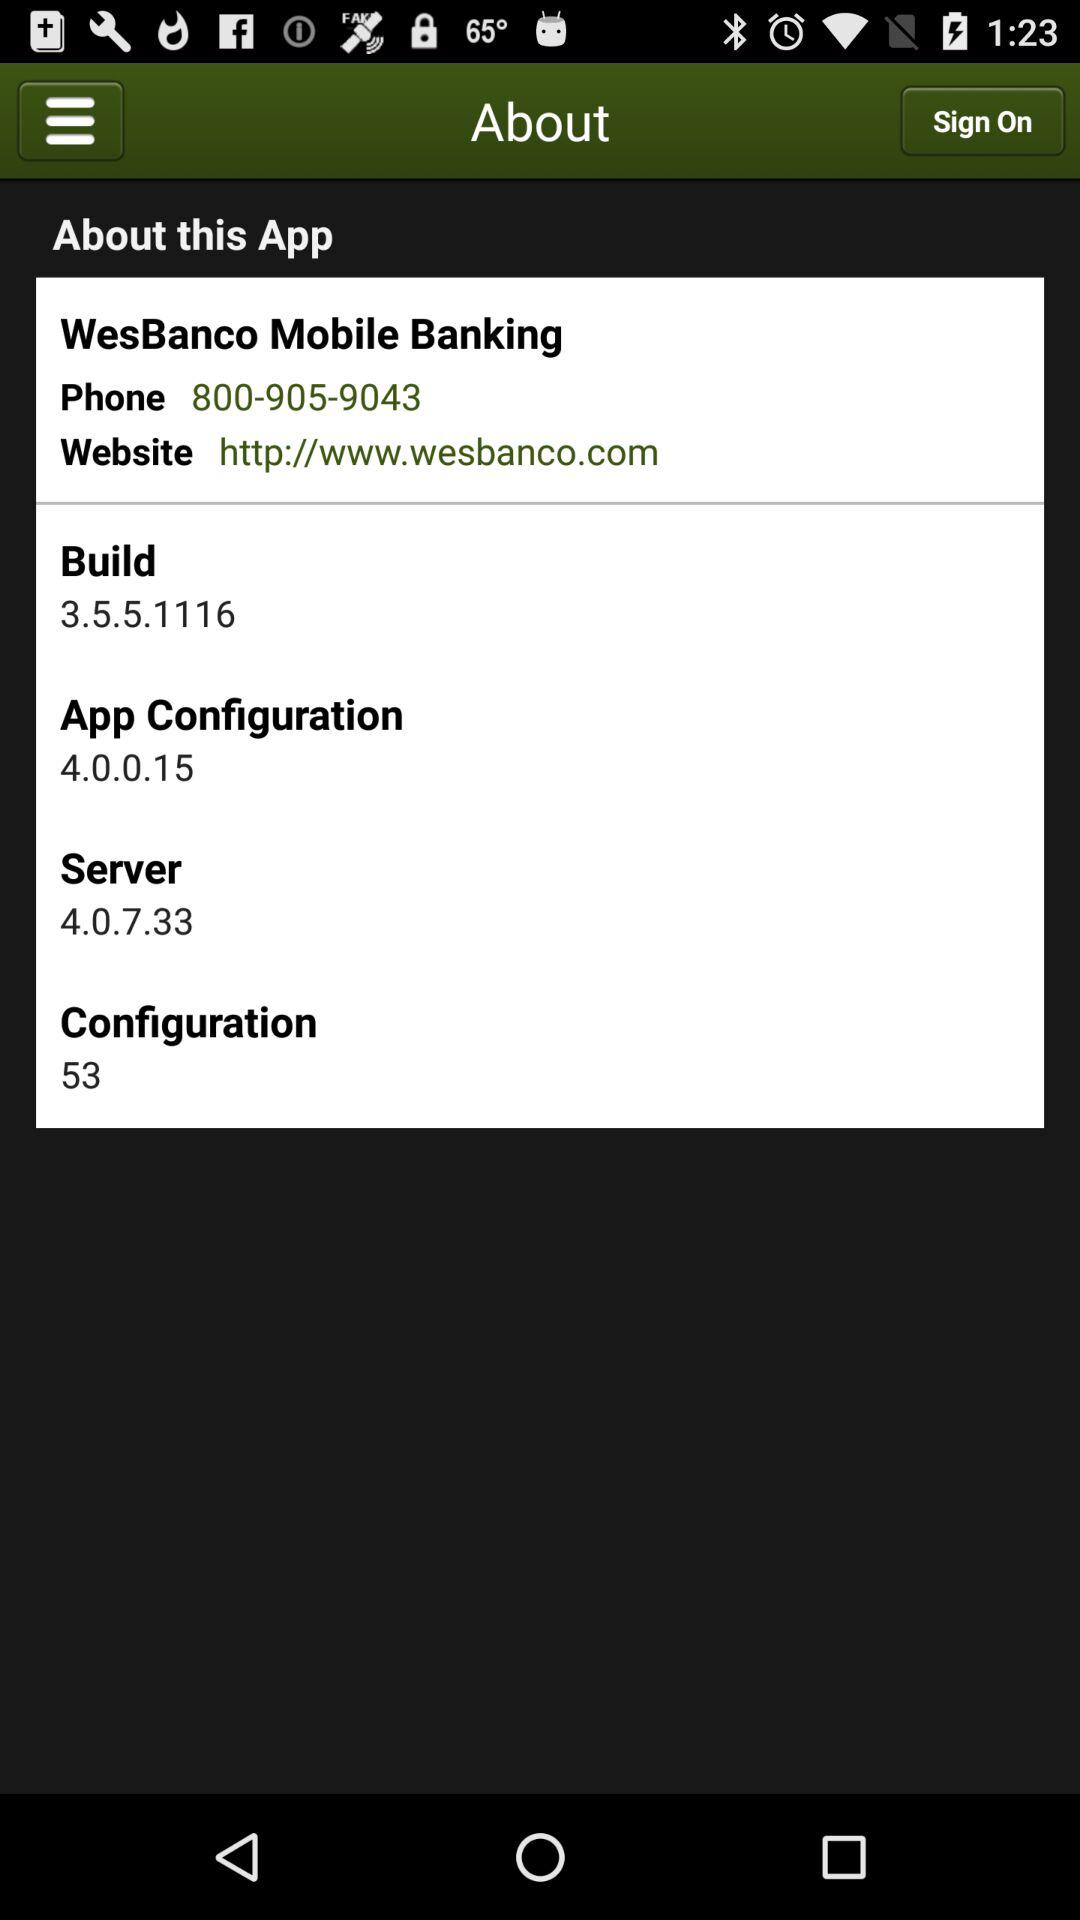What is the number of the server? The server number is 4.0.7.33. 